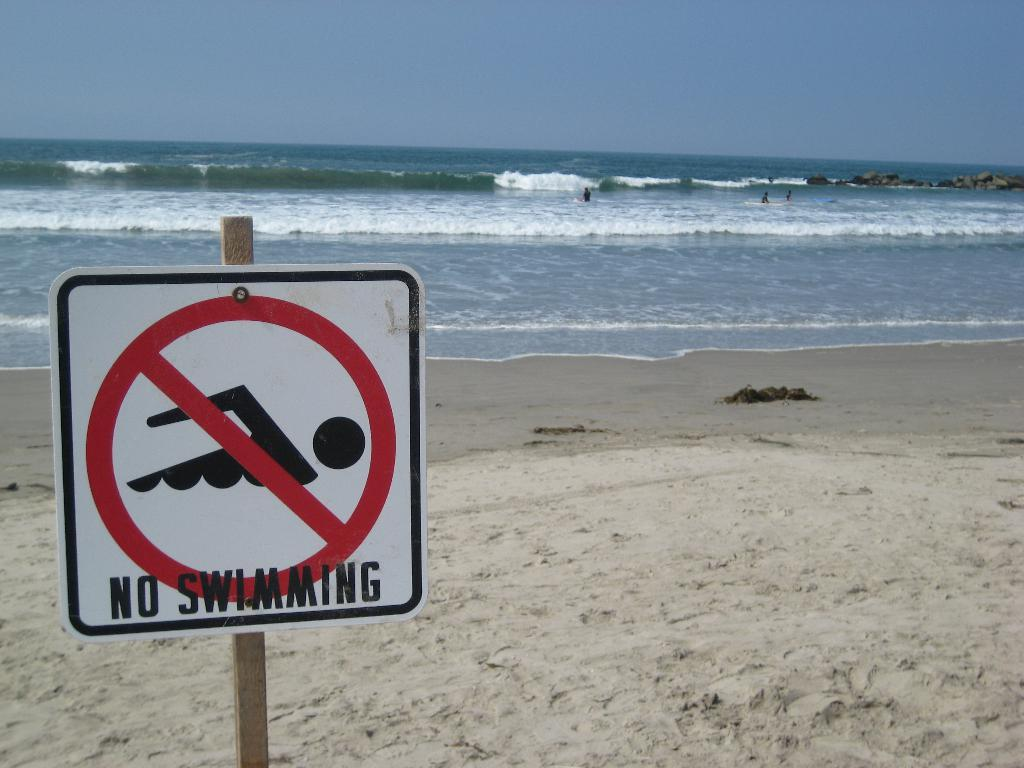<image>
Share a concise interpretation of the image provided. A signpost is in the sand before a choppy sea which forbids swimming. 